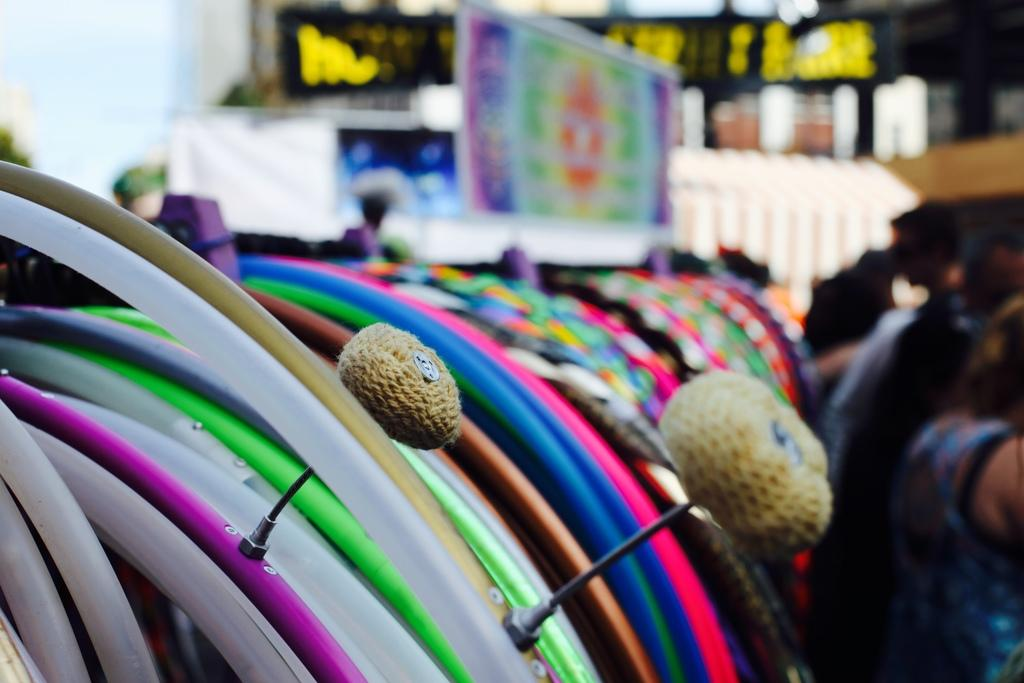What shape is the object in the image? The object in the image is circle-shaped. What can be said about the colors of the object? The object has different colors. Can you describe the presence of a person in the image? There is a lady on the right side of the image. What type of honey is being used by the lady in the image? There is no honey present in the image, and the lady is not performing any action that would involve using honey. 